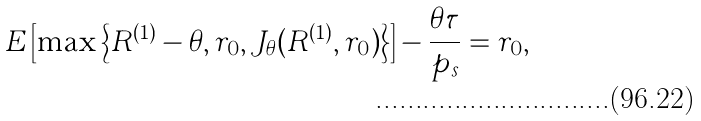Convert formula to latex. <formula><loc_0><loc_0><loc_500><loc_500>E \left [ \max \left \{ R ^ { ( 1 ) } - \theta , r _ { 0 } , J _ { \theta } ( R ^ { ( 1 ) } , r _ { 0 } ) \right \} \right ] - \frac { \theta \tau } { p _ { s } } = r _ { 0 } ,</formula> 